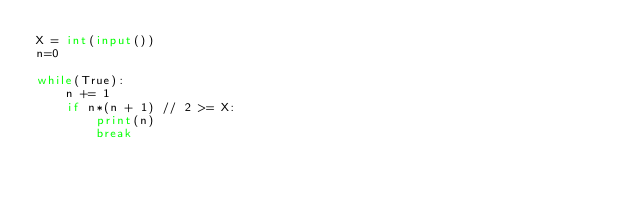Convert code to text. <code><loc_0><loc_0><loc_500><loc_500><_Python_>X = int(input())
n=0

while(True):
    n += 1
    if n*(n + 1) // 2 >= X:
        print(n)
        break
</code> 